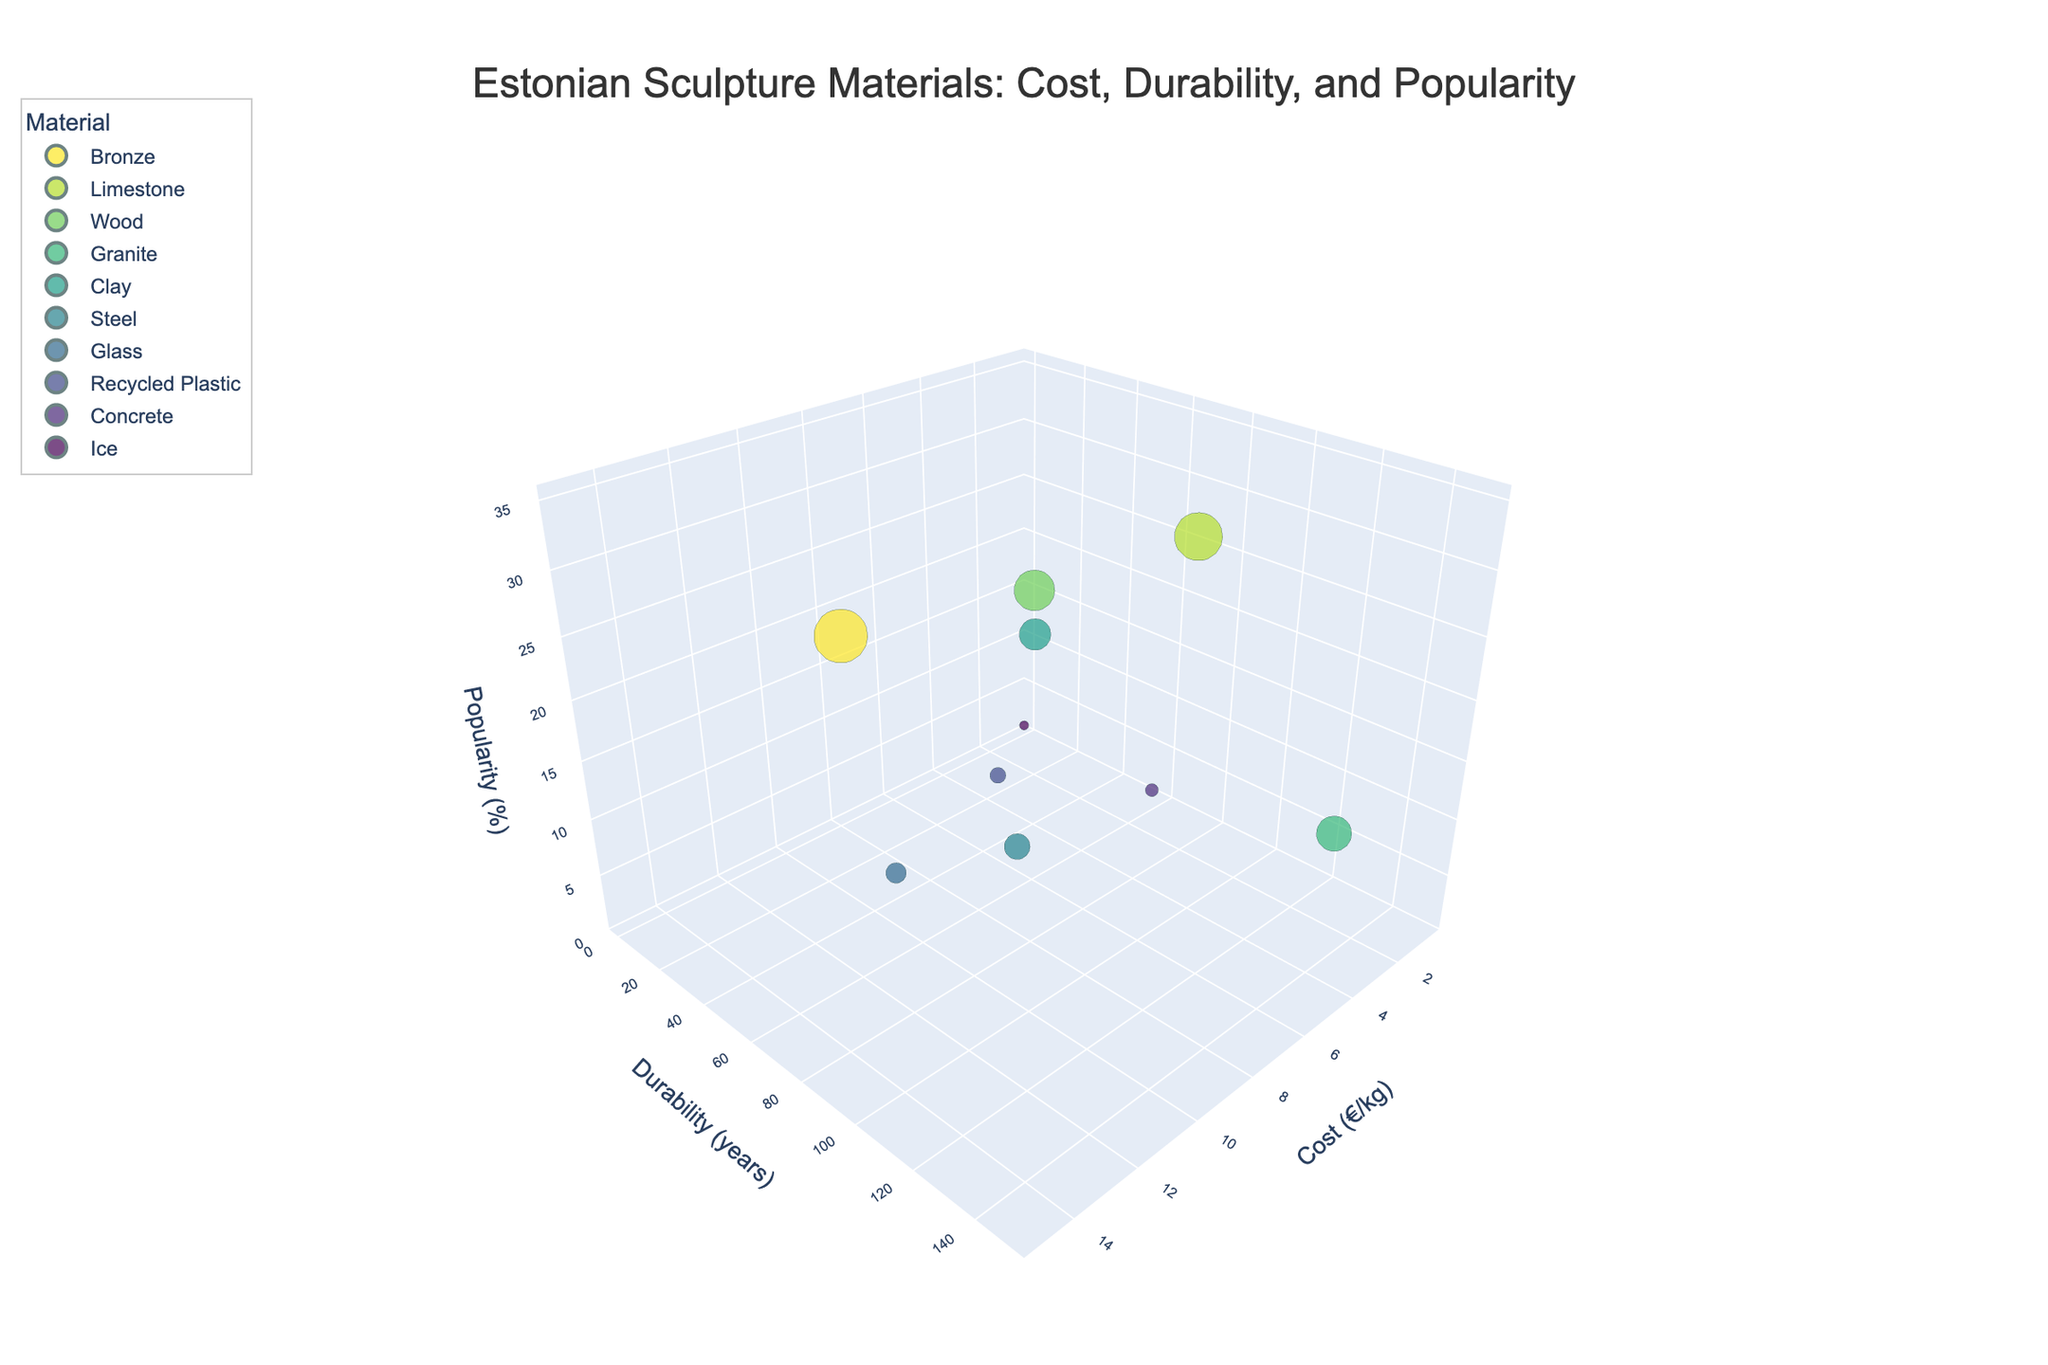How does cost relate to durability for the materials? By observing the scatter of the points in the 3D space, we can infer any trend between cost and durability. Here, we need to look at the elements in the cost (x-axis) and durability (y-axis) and check their correlation.
Answer: There's no clear trend Which material is the most durable? The material with the highest value on the y-axis (Durability) is the most durable. From the chart data, this corresponds to the highest point along the y-axis.
Answer: Granite What is the cost and durability of recycled plastic? By identifying the position of Recycled Plastic in the chart, we can locate its coordinates along the cost and durability axes.
Answer: €4/kg and 25 years Which material has the lowest cost and what is its popularity? The material with the minimum value on the x-axis (Cost) has the lowest cost. From the chart data, we can identify the corresponding popularity value on the z-axis.
Answer: Ice, 1% How does the popularity of bronze compare to steel? To compare the popularity of bronze and steel, we examine their respective positions along the z-axis (Popularity).
Answer: Bronze is more popular than Steel Which material has an equal cost to wood but is more popular? Locate the data point for Wood on the x-axis for cost, then check other materials with the same x-value and compare their z-values for popularity.
Answer: Limestone What are the average durability and cost of the materials used? To find averages, sum up all values of durability and cost, then divide by the count of materials. Perform these calculations based on the provided data.
Answer: Durability: 58.01 years, Cost: €4.35/kg What is the size of the bubble representing bronze? The size of the bubble corresponds to the popularity percentage. Look for the popularity value for bronze.
Answer: 35% How do the popularity and cost of glass compare to those of concrete? Compare the positions of glass and concrete in the 3D space, particularly on the axes of popularity (z-axis) and cost (x-axis).
Answer: Glass is more popular and costs more 